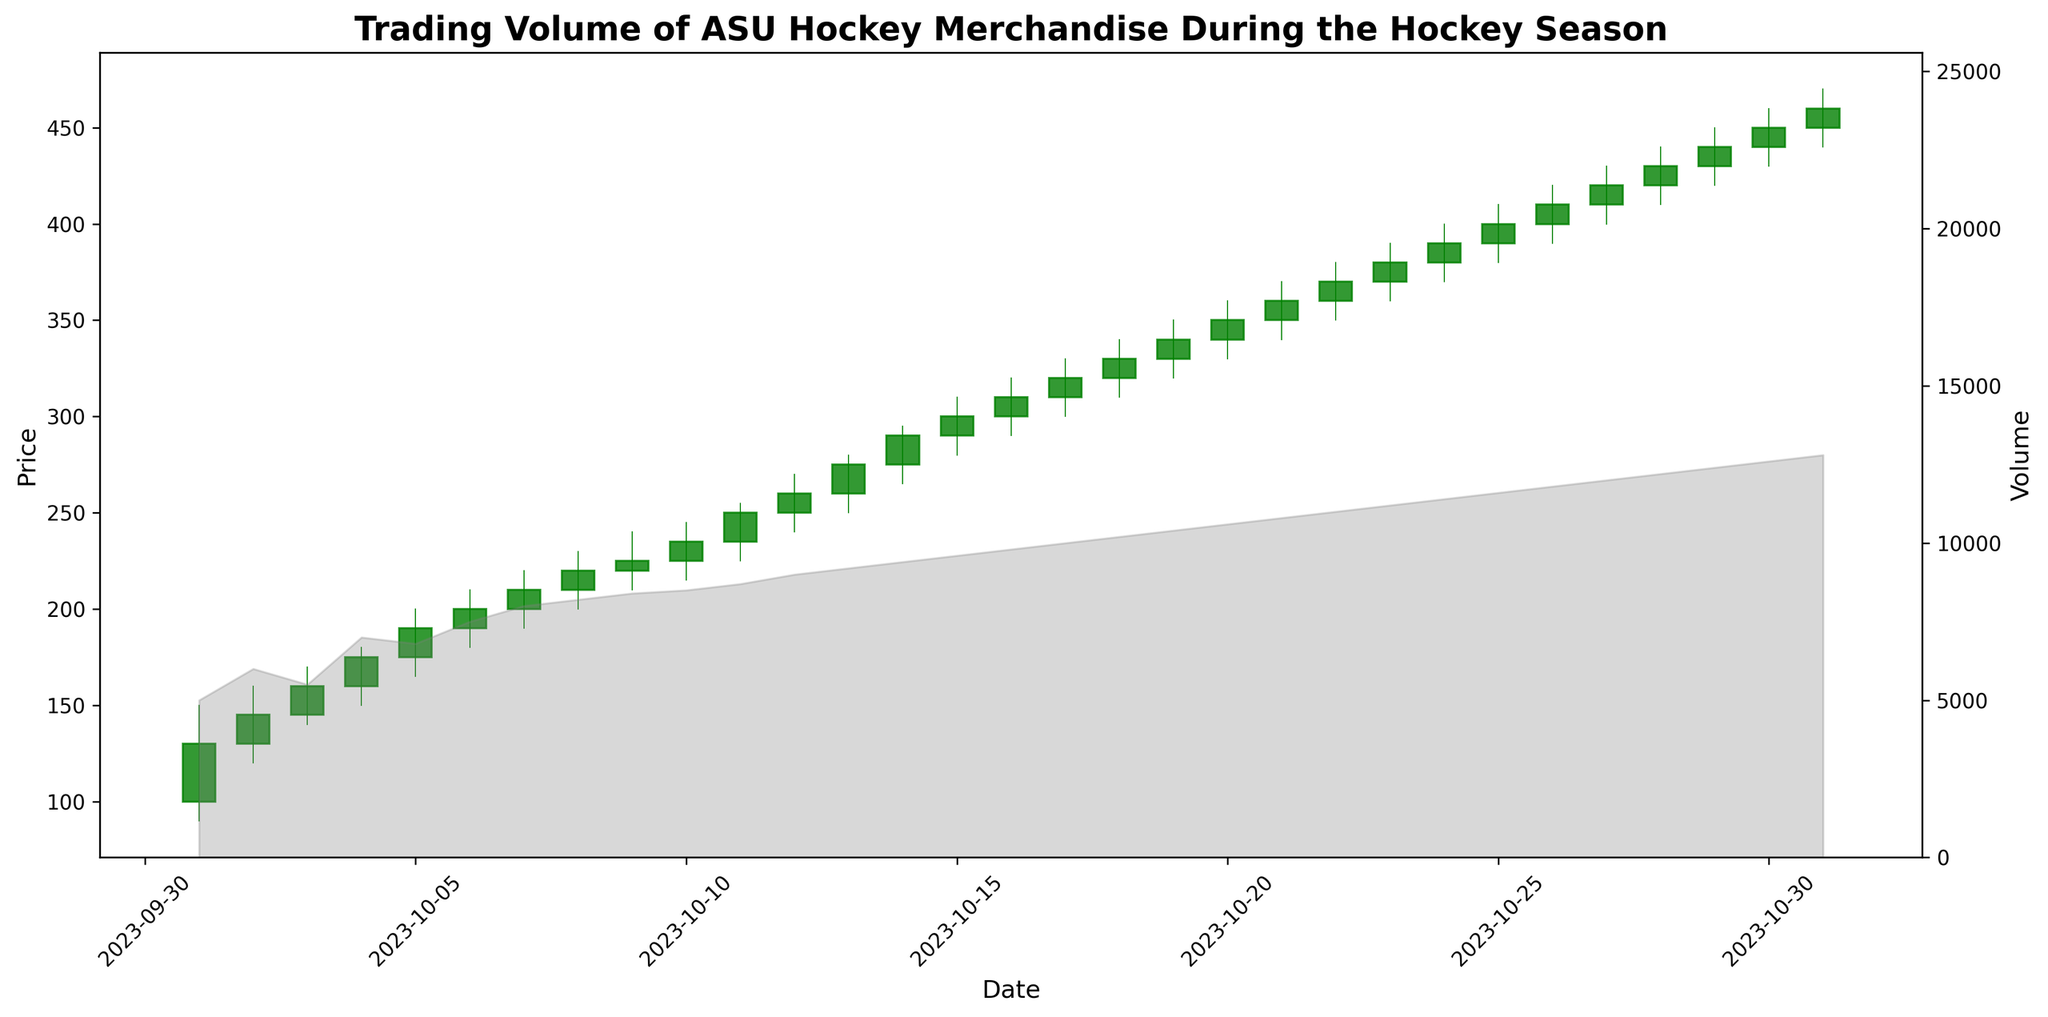What was the highest closing price during the period shown in the figure? To find the highest closing price, look for the peak point in the closing price data plot. This point can be observed on the line graph indicating closing prices. The highest closing price is on 2023-10-31 with the price of 460.
Answer: 460 On which date did the trading volume first exceed 10,000? To find the date when the trading volume first exceeds 10,000, examine the secondary y-axis of the plot that shows trading volume. Check the date where the grey filled volume plot crosses the 10,000 mark for the first time. The trading volume first exceeds 10,000 on 2023-10-17.
Answer: 2023-10-17 Which day had the most significant increase in closing price compared to the previous day? Calculate the difference in closing prices between consecutive days and identify the maximum difference. Compare the closing prices shown on the line graph for each date and subtract the previous day's closing price. The largest increase in closing price from 2023-10-24 to 2023-10-25 is from 390 to 400.
Answer: 2023-10-25 What is the average volume over the period? To find the average volume, sum up all the volume values and divide by the number of days. The total sum of volumes is 289,200. Dividing by the 31 days gives an average trading volume of 9,329.
Answer: 9,329 On which date did the lowest price occur, and what was its value? Identify the minimum price from the low data on the plot. Look for the lowest point in the candlestick plot which represents the lowest price. The lowest price of 90 occurred on 2023-10-01.
Answer: 2023-10-01, 90 What was the closing price on October 10, 2023? Find the closing price on 2023-10-10 by locating the corresponding candlestick and noting the closing value. The closing price on 2023-10-10 was 235.
Answer: 235 How many days did the price close higher than it opened? Count the number of days where the closing price is higher than the opening price by examining the candlesticks. If the candlestick is green, the price closed higher than it opened. There are 23 such days.
Answer: 23 Which day had the smallest trading volume? Identify the lowest point in the grey filled volume plot. Look at the volume values on the secondary y-axis and corresponding dates. The smallest trading volume of 5,000 occurred on 2023-10-01.
Answer: 2023-10-01 What's the difference between the highest and lowest closing prices? To find the difference, subtract the lowest closing price from the highest closing price. The highest closing price is 460, and the lowest is 130. Therefore, the difference is 460 - 130 = 330.
Answer: 330 